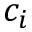Convert formula to latex. <formula><loc_0><loc_0><loc_500><loc_500>c _ { i }</formula> 